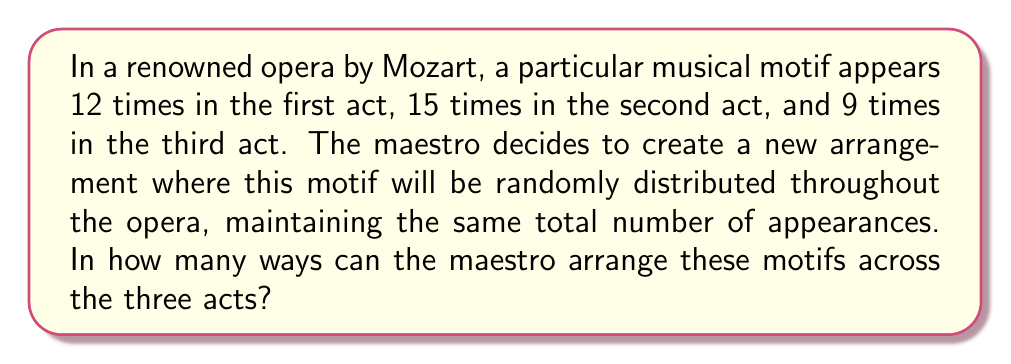Show me your answer to this math problem. To solve this problem, we can use the concept of combinations with repetition, also known as stars and bars or multichoose.

Let's approach this step-by-step:

1) First, we need to calculate the total number of times the motif appears:
   $12 + 15 + 9 = 36$ times in total

2) Now, we need to distribute these 36 indistinguishable motifs into 3 distinguishable acts.

3) This scenario is equivalent to choosing 2 dividers to separate the 36 motifs into 3 groups, which can be represented as:
   $\circ\circ\circ\circ ... \circ | \circ\circ\circ ... \circ | \circ\circ\circ ... \circ$
   where $\circ$ represents a motif and $|$ represents a divider.

4) The number of ways to do this is given by the combination formula:

   $$\binom{n+k-1}{k-1} = \binom{n+k-1}{n}$$

   where $n$ is the number of indistinguishable objects (motifs) and $k$ is the number of distinguishable groups (acts).

5) In this case, $n = 36$ and $k = 3$. So we need to calculate:

   $$\binom{36+3-1}{3-1} = \binom{38}{2}$$

6) We can calculate this as:

   $$\binom{38}{2} = \frac{38!}{2!(38-2)!} = \frac{38 \cdot 37}{2 \cdot 1} = 703$$

Therefore, there are 703 ways for the maestro to arrange these motifs across the three acts.
Answer: 703 